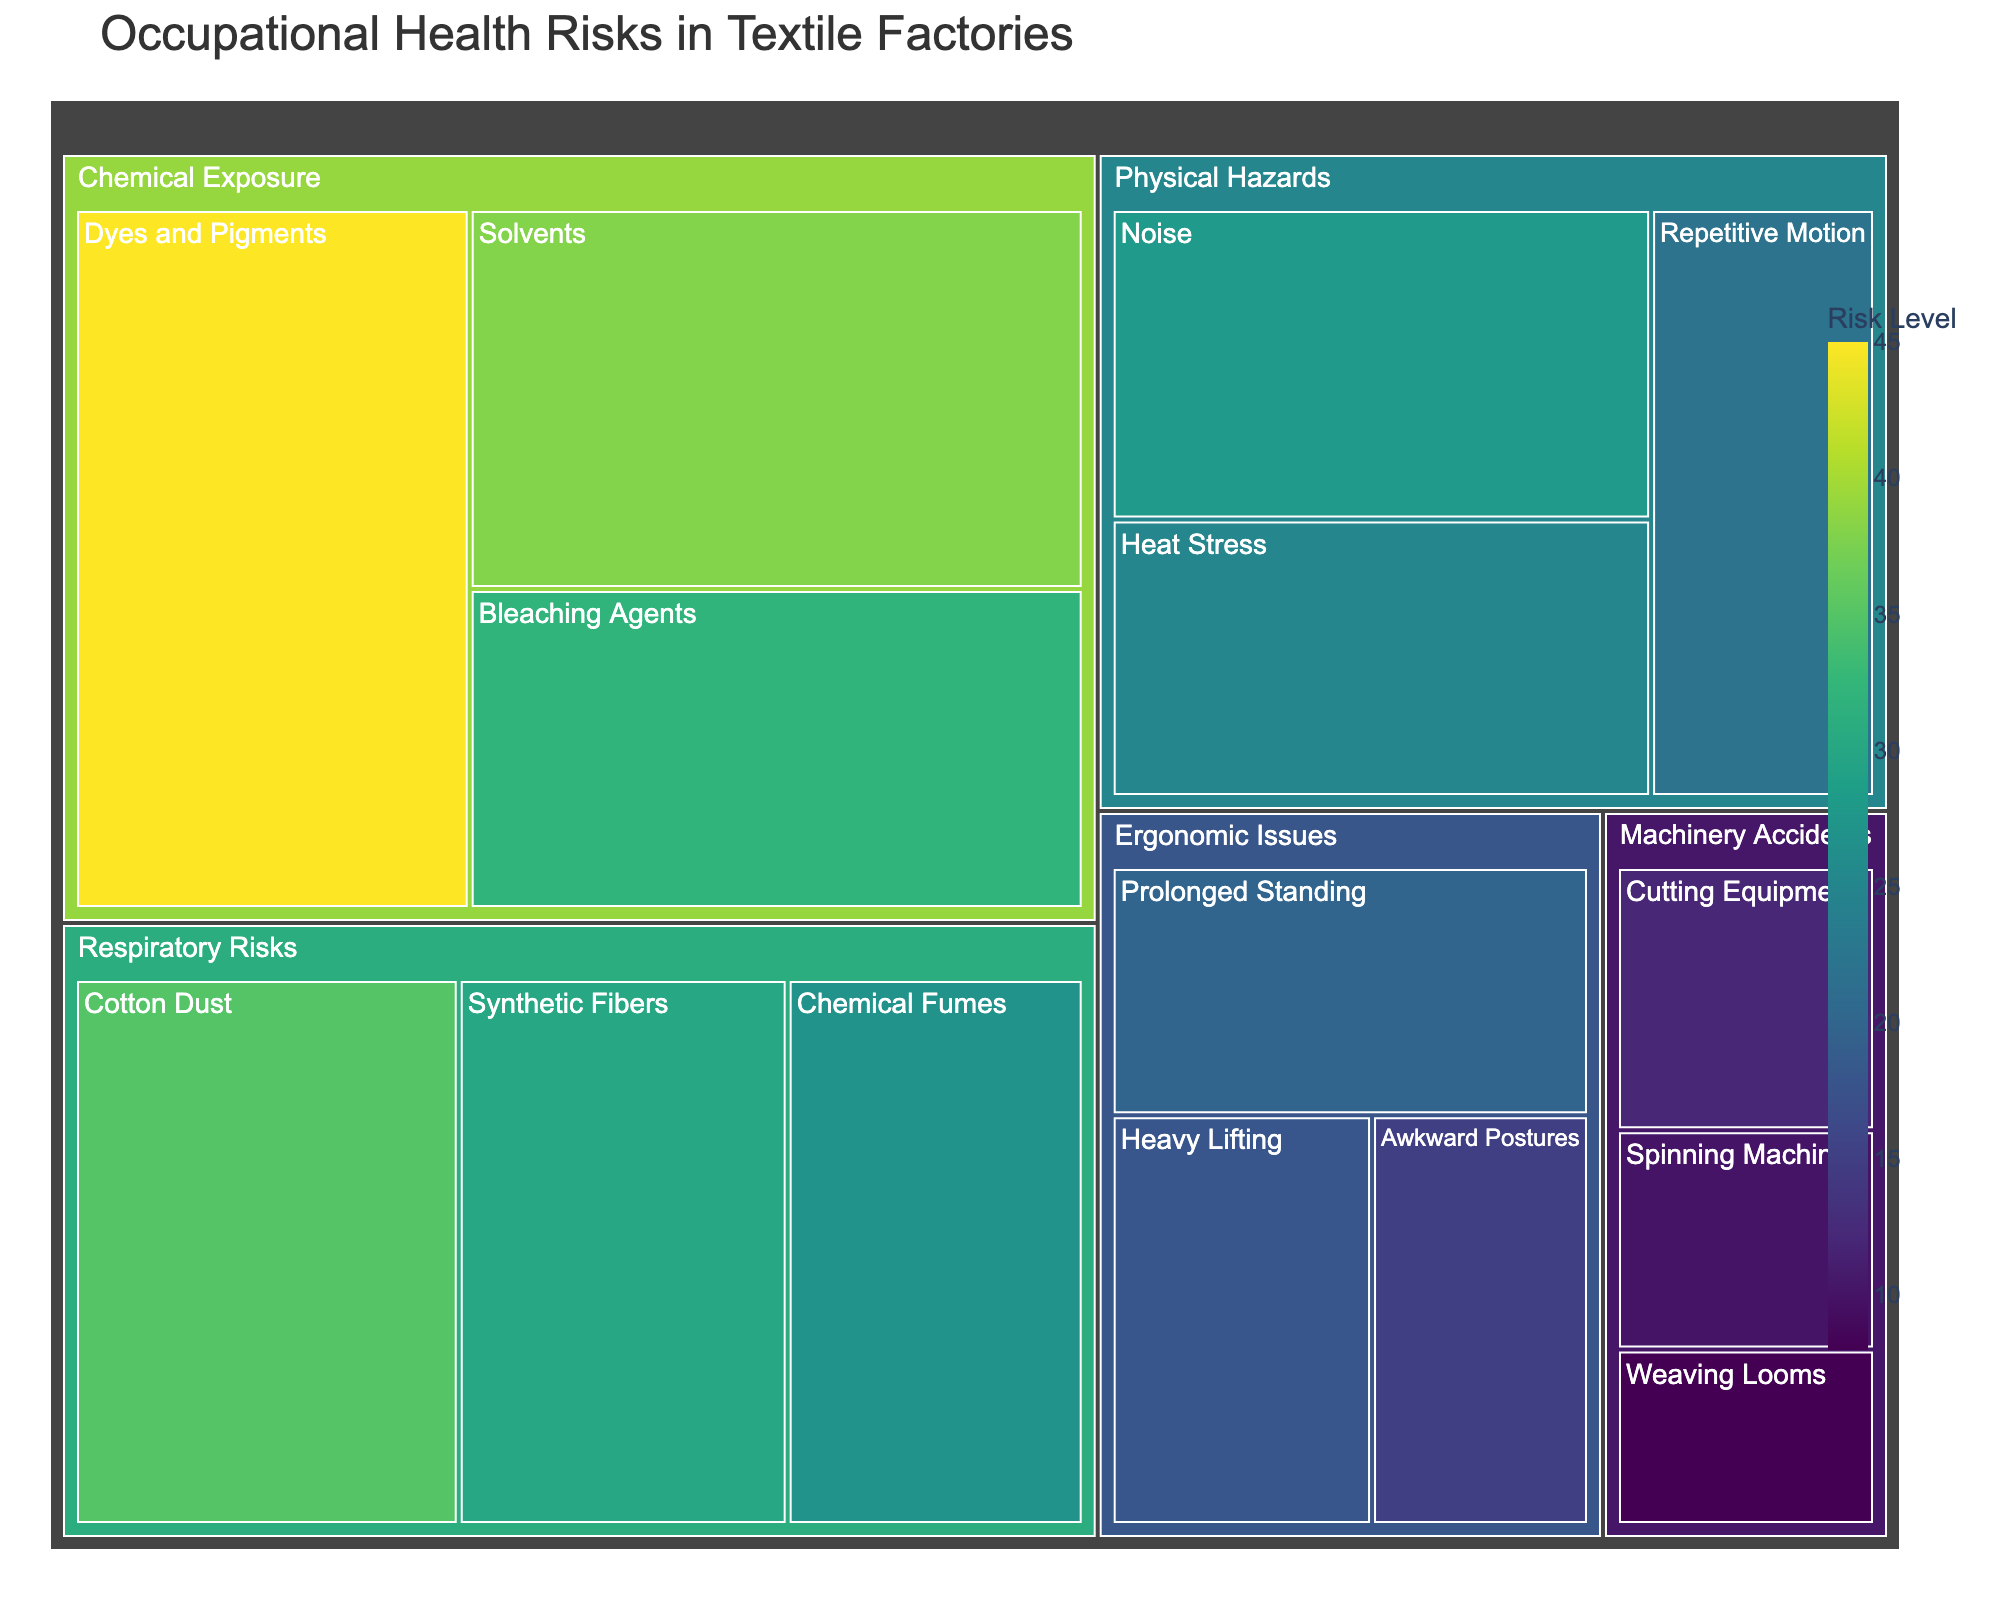what is the title of the figure? The title can be identified by looking at the top of the figure, which generally contains the chart or graph's purpose or topic. In this treemap, the title is "Occupational Health Risks in Textile Factories".
Answer: Occupational Health Risks in Textile Factories What is the highest risk subcategory within 'Chemical Exposure'? Look at the blocks within the 'Chemical Exposure' category and identify which one has the highest numerical value in the Risk column. The subcategory 'Dyes and Pigments' has a risk value of 45, which is the highest within 'Chemical Exposure'.
Answer: Dyes and Pigments How does the risk from 'Noise' compare to 'Heat Stress'? Compare the numerical values of the risk for 'Noise' and 'Heat Stress' in the 'Physical Hazards' category. 'Noise' has a risk value of 28, whereas 'Heat Stress' has a risk value of 25. Noise is 3 units higher than Heat Stress.
Answer: Noise has a higher risk by 3 units What is the total risk for all 'Physical Hazards'? Add the risk values for all subcategories within 'Physical Hazards': Noise (28), Heat Stress (25), and Repetitive Motion (22). The sum is 28 + 25 + 22 = 75.
Answer: 75 Identify which exposure type (category) has the lowest total risk. Sum the risks within each category and compare: 
Chemical Exposure (45 + 38 + 32 = 115), Physical Hazards (28 + 25 + 22 = 75), Respiratory Risks (35 + 30 + 27 = 92), Ergonomic Issues (20 + 18 + 15 = 53), Machinery Accidents (12 + 10 + 8 = 30). Machinery Accidents has the lowest total risk.
Answer: Machinery Accidents Which subcategory has the lowest risk, and what is its value? Look for the smallest numerical value in the Risk column. 'Weaving Looms' in the Machinery Accidents category has the lowest risk value of 8.
Answer: Weaving Looms with a risk of 8 Within 'Ergonomic Issues', what is the average risk value? Sum the risk values (Prolonged Standing 20, Heavy Lifting 18, Awkward Postures 15) and divide by the number of subcategories: (20 + 18 + 15) / 3 = 53 / 3. The average risk value is approximately 17.67.
Answer: 17.67 What proportion of the total risk for 'Chemical Exposure' comes from 'Solvents'? Calculate the total risk for 'Chemical Exposure' (45 + 38 + 32 = 115) and then find the proportion from 'Solvents': 38 / 115 ≈ 0.33 or 33%.
Answer: 33% Which 'Respiratory Risks' subcategory has the closest risk value to 'Repetitive Motion' under 'Physical Hazards'? Compare the risk values: 'Repetitive Motion' is 22. For 'Respiratory Risks', 'Chemical Fumes' is 27, 'Synthetic Fibers' is 30, and 'Cotton Dust' is 35. The closest value is 'Chemical Fumes' with a risk value of 27.
Answer: Chemical Fumes What are the combined risks of all subcategories under 'Ergonomic Issues' and 'Machinery Accidents'? Add the total risks of each category: Ergonomic Issues (20 + 18 + 15 = 53) and Machinery Accidents (12 + 10 + 8 = 30). The combined risk is 53 + 30 = 83.
Answer: 83 